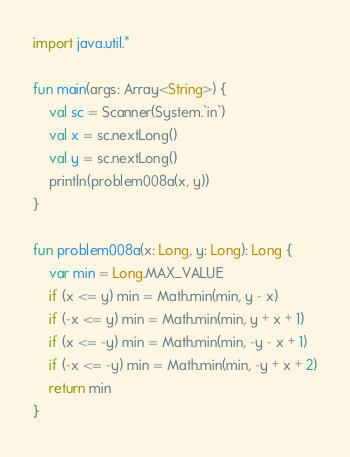<code> <loc_0><loc_0><loc_500><loc_500><_Kotlin_>import java.util.*

fun main(args: Array<String>) {
    val sc = Scanner(System.`in`)
    val x = sc.nextLong()
    val y = sc.nextLong()
    println(problem008a(x, y))
}

fun problem008a(x: Long, y: Long): Long {
    var min = Long.MAX_VALUE
    if (x <= y) min = Math.min(min, y - x)
    if (-x <= y) min = Math.min(min, y + x + 1)
    if (x <= -y) min = Math.min(min, -y - x + 1)
    if (-x <= -y) min = Math.min(min, -y + x + 2)
    return min
}</code> 